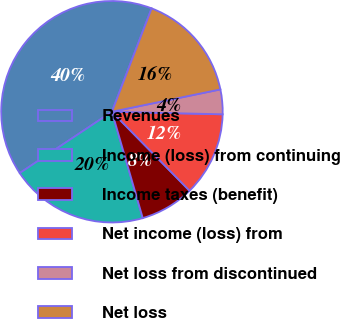<chart> <loc_0><loc_0><loc_500><loc_500><pie_chart><fcel>Revenues<fcel>Income (loss) from continuing<fcel>Income taxes (benefit)<fcel>Net income (loss) from<fcel>Net loss from discontinued<fcel>Net loss<nl><fcel>40.18%<fcel>20.15%<fcel>7.87%<fcel>12.27%<fcel>3.6%<fcel>15.93%<nl></chart> 